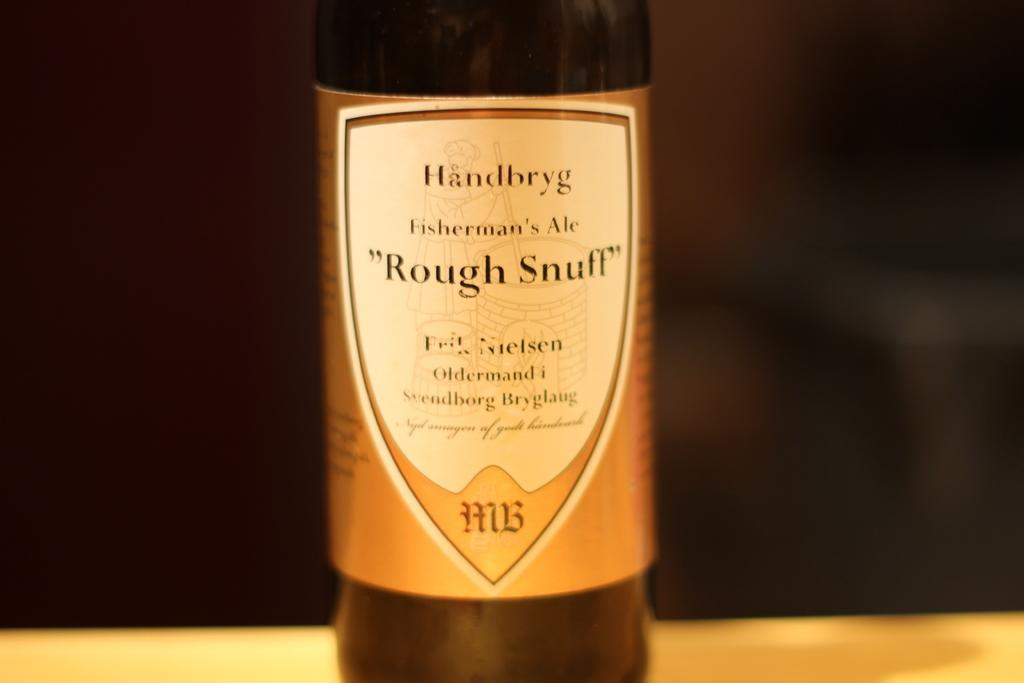<image>
Provide a brief description of the given image. a bottle label of rough stnuff the fishermans ale by handbryg 